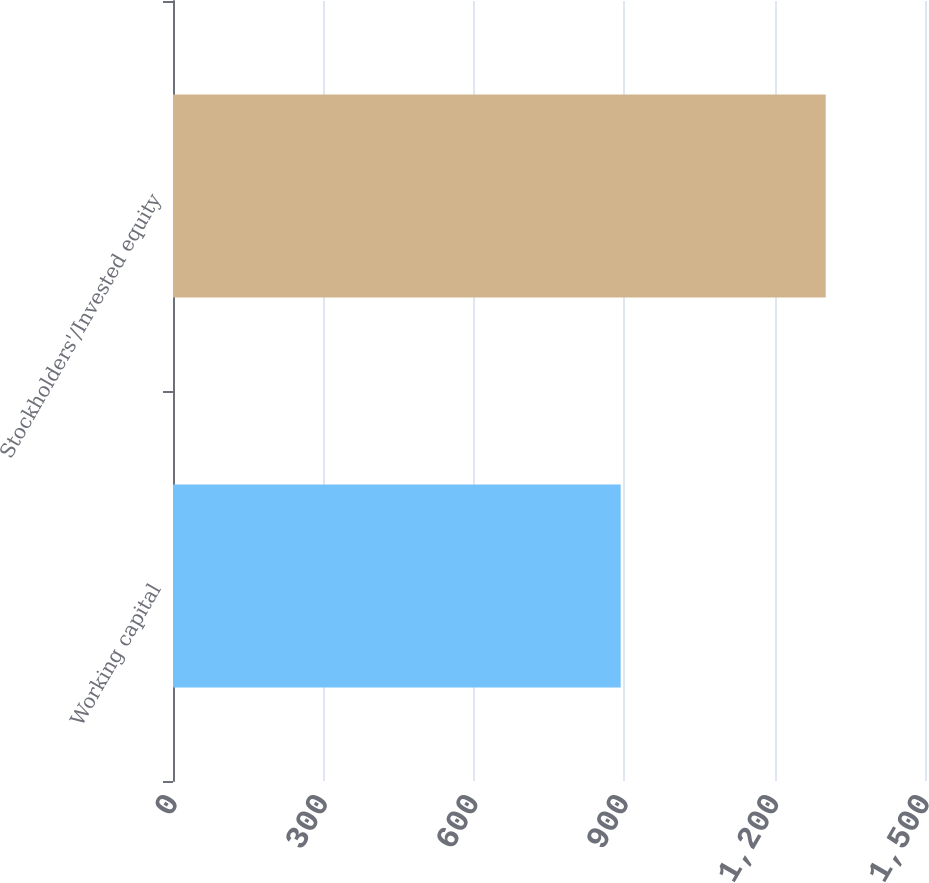<chart> <loc_0><loc_0><loc_500><loc_500><bar_chart><fcel>Working capital<fcel>Stockholders'/Invested equity<nl><fcel>893<fcel>1302<nl></chart> 